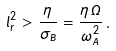Convert formula to latex. <formula><loc_0><loc_0><loc_500><loc_500>l _ { r } ^ { 2 } > \frac { \eta } { \sigma _ { B } } = \frac { \eta \, \Omega } { \omega _ { A } ^ { 2 } } \, .</formula> 